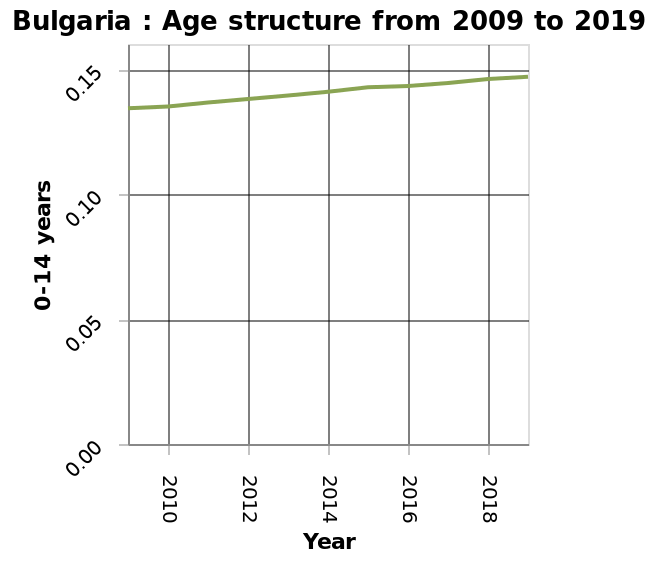<image>
What can be observed about the age of structures over the years? The age of structures has been consistently increasing over the years. What is happening to the age of structures over the years?  The age of structures is steadily rising over the years. 